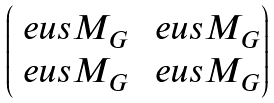<formula> <loc_0><loc_0><loc_500><loc_500>\begin{pmatrix} \ e u s M _ { G } & \ e u s M _ { G } \\ \ e u s M _ { G } & \ e u s M _ { G } \end{pmatrix}</formula> 